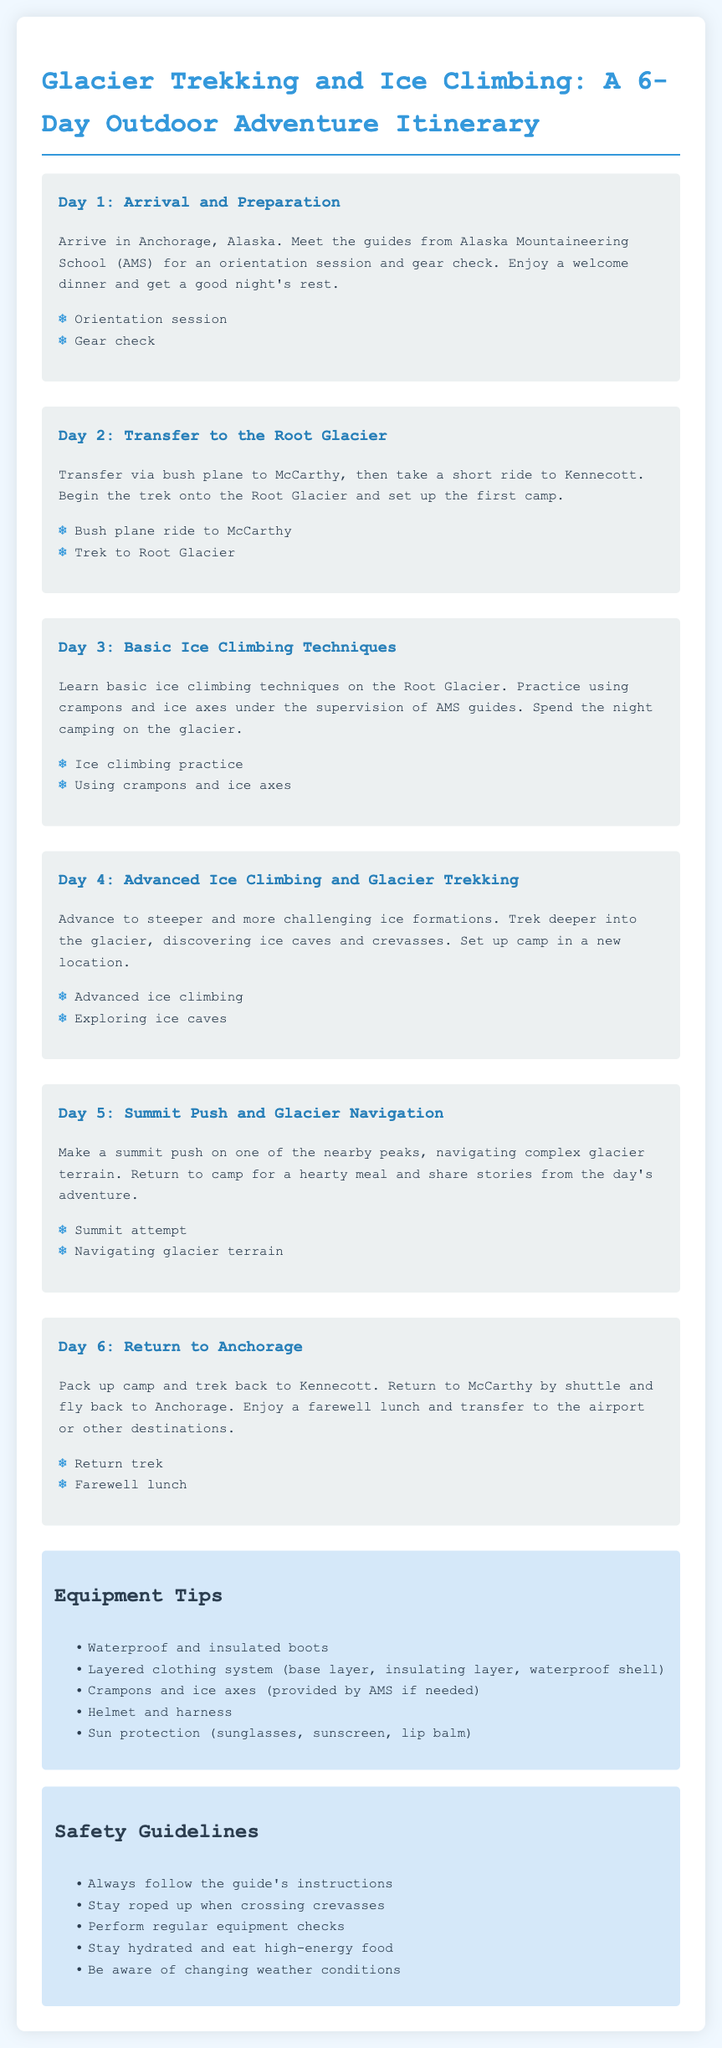What is the first day's activity? The first day's activity includes an orientation session and gear check upon arrival in Anchorage.
Answer: Orientation session What is the name of the guiding organization? The document mentions Alaska Mountaineering School (AMS) as the guiding organization for the trek.
Answer: Alaska Mountaineering School What types of climbing skills are learned on Day 3? On Day 3, the itinerary specifies that participants learn basic ice climbing techniques.
Answer: Basic ice climbing techniques What safety guideline mentions weather awareness? The safety guideline about being aware of changing weather conditions emphasizes the importance of monitoring weather.
Answer: Be aware of changing weather conditions How many days does the outdoor adventure last? The itinerary outlines a total of 6 days for the outdoor adventure.
Answer: 6 days What is included in the equipment tips for sun protection? The equipment tips specifically mention sunglasses, sunscreen, and lip balm for sun protection.
Answer: Sunglasses, sunscreen, lip balm What universal rule is highlighted for safety during glacier crossings? The guideline states that participants must stay roped up when crossing crevasses for safety.
Answer: Stay roped up when crossing crevasses Which activity occurs on Day 5? On Day 5, the activity is making a summit push and navigating complex glacier terrain.
Answer: Summit push and glacier navigation 